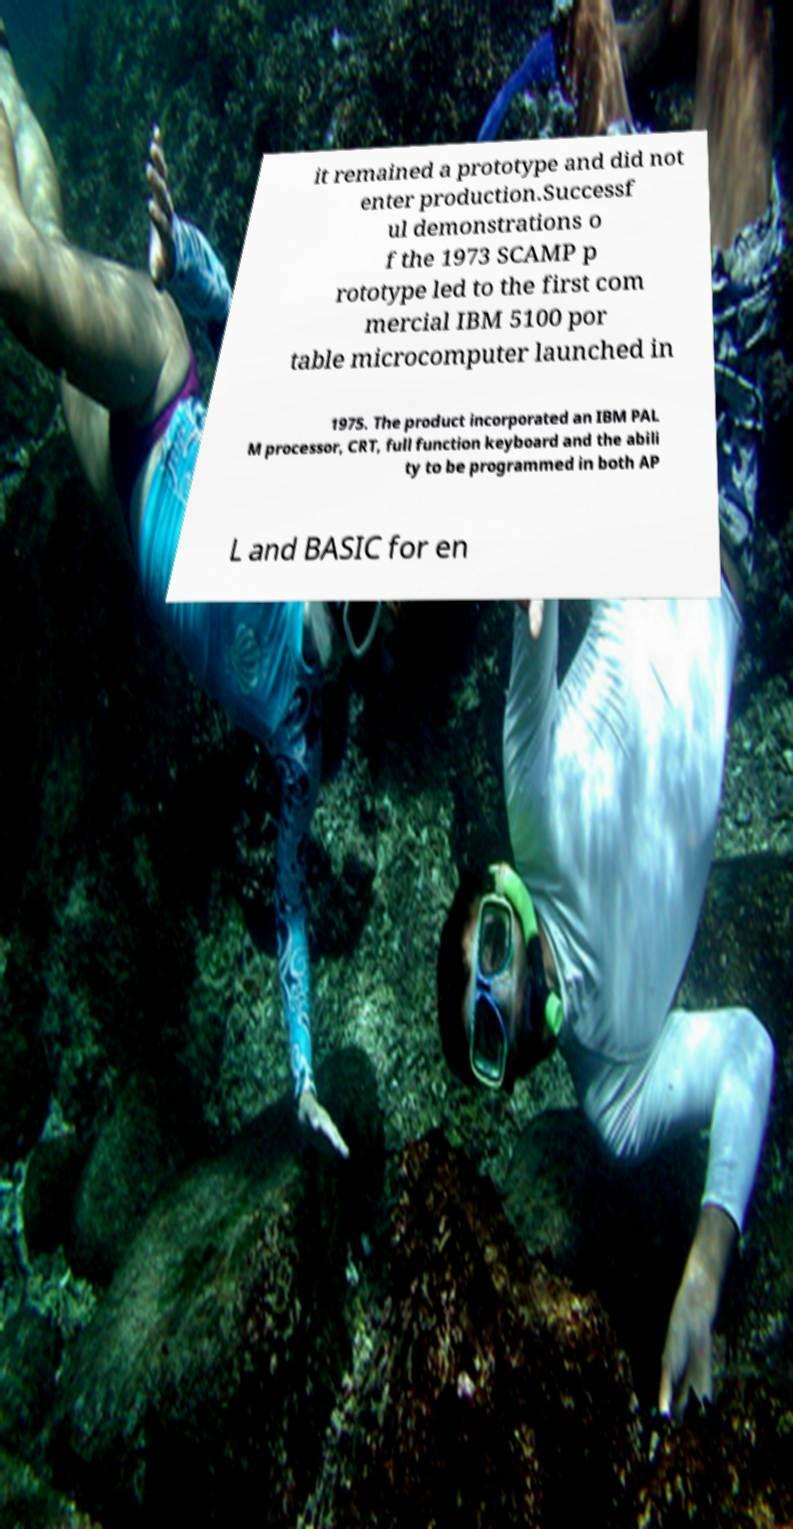Can you accurately transcribe the text from the provided image for me? it remained a prototype and did not enter production.Successf ul demonstrations o f the 1973 SCAMP p rototype led to the first com mercial IBM 5100 por table microcomputer launched in 1975. The product incorporated an IBM PAL M processor, CRT, full function keyboard and the abili ty to be programmed in both AP L and BASIC for en 